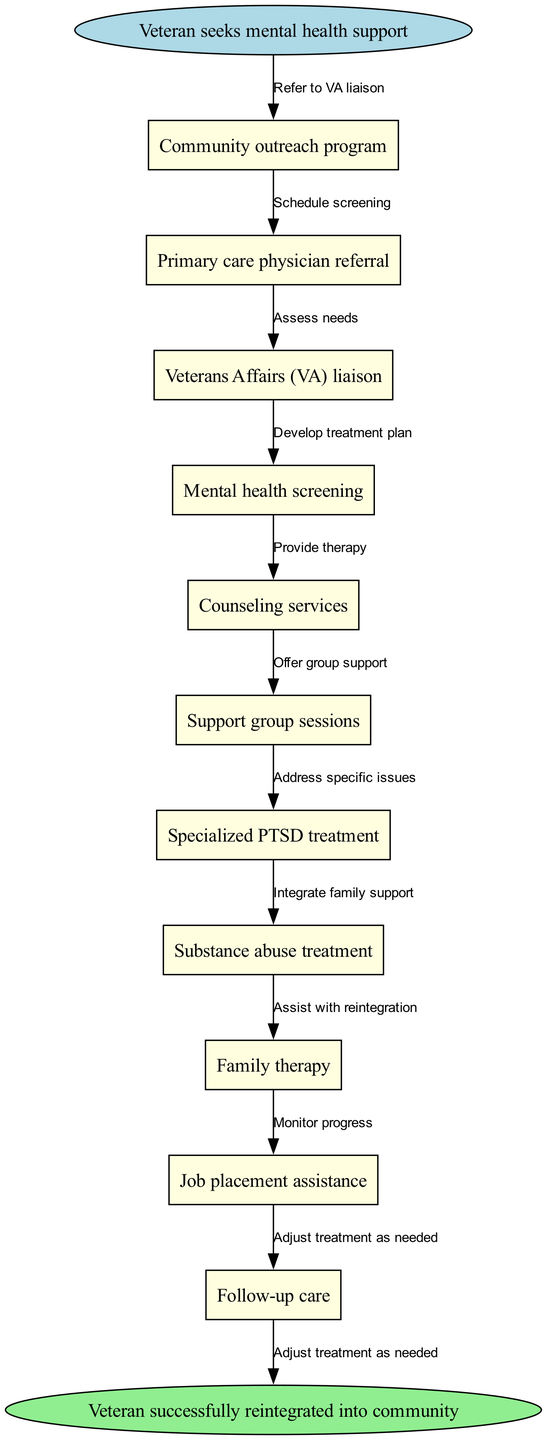What is the starting point of the pathway? The pathway begins with the "Veteran seeks mental health support" node. This can be identified as the first node in the diagram.
Answer: Veteran seeks mental health support How many nodes are present in the diagram? There are 10 total nodes identified: 1 start, 8 intermediate, and 1 end node, making a sum of 10.
Answer: 10 What is the last step of the pathway? The last step before concluding the pathway is "Follow-up care," which directly leads to the end node. This is the last intermediate node identified before reaching the final conclusion of the pathway.
Answer: Follow-up care Which service is provided after "Mental health screening"? Following the "Mental health screening" node, the pathway proceeds to "Counseling services" as indicated by the connecting edge.
Answer: Counseling services What connects "Community outreach program" and "Primary care physician referral"? The "Refer to VA liaison" edge connects these two nodes. This indicates an action that takes place between them in the pathway.
Answer: Refer to VA liaison What type of therapy is specifically mentioned in the pathway for veterans dealing with trauma? The pathway specifically mentions "Specialized PTSD treatment," indicating the specific mental health support provided to veterans affected by trauma.
Answer: Specialized PTSD treatment Which node indicates a step towards job assistance for veterans? The "Job placement assistance" node represents a step specifically aimed at assisting veterans with employment, indicated within the pathway layout.
Answer: Job placement assistance How does the pathway integrate family support? The pathway includes "Family therapy," indicating that family support is integrated as part of the comprehensive treatment options available to veterans.
Answer: Family therapy What step involves monitoring the veteran's progress? The "Monitor progress" step refers to the requirement to check on the veteran's advancement through the treatment plan, indicating ongoing evaluation.
Answer: Monitor progress 